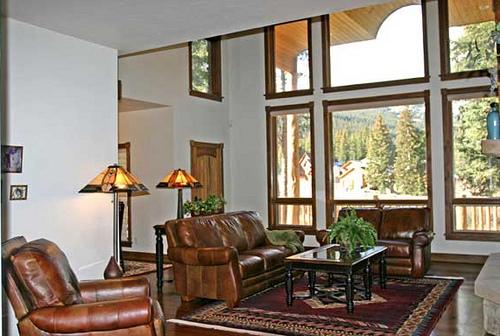Are these leather couches?
Concise answer only. Yes. What is the color of the couch?
Give a very brief answer. Brown. What color is the area rug?
Be succinct. Red. Are the windows symmetrical?
Give a very brief answer. Yes. 